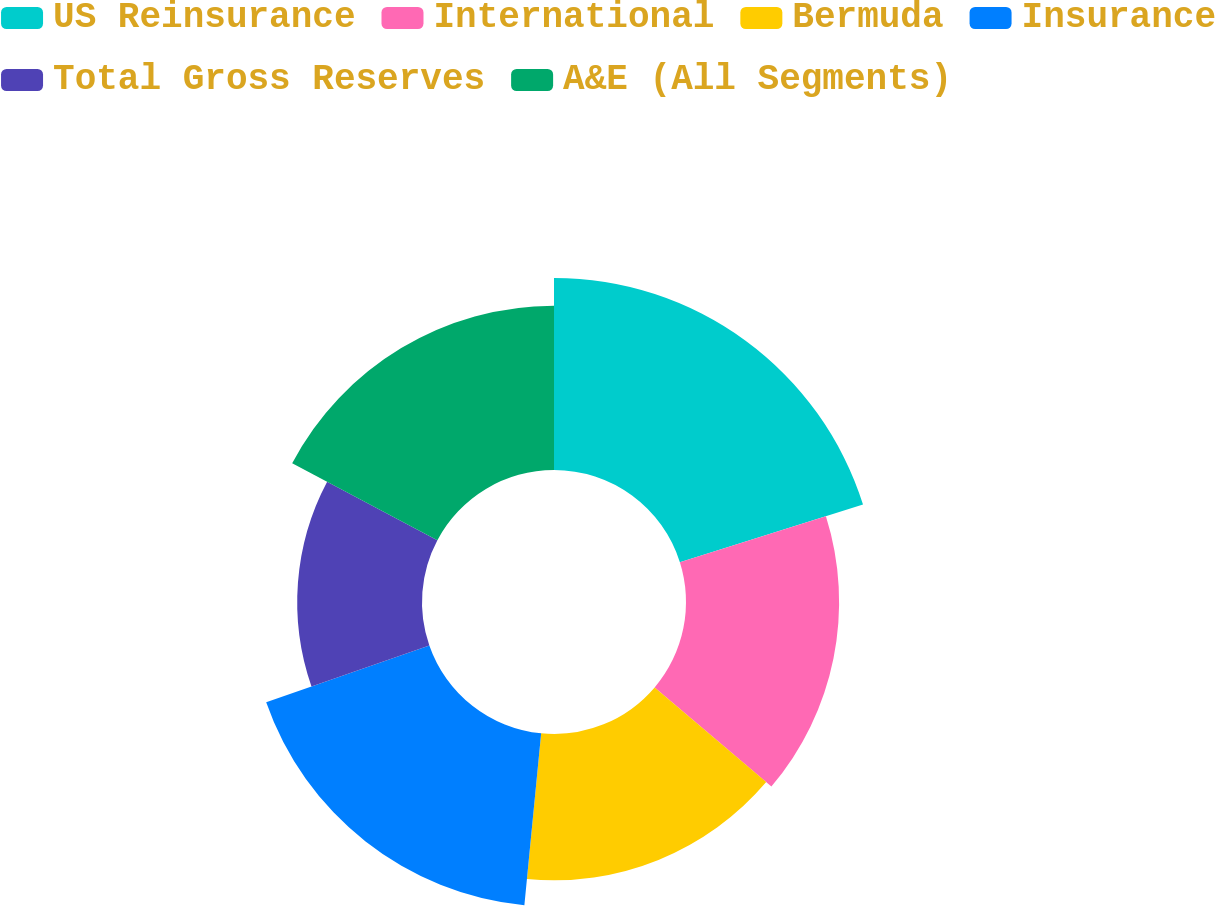Convert chart. <chart><loc_0><loc_0><loc_500><loc_500><pie_chart><fcel>US Reinsurance<fcel>International<fcel>Bermuda<fcel>Insurance<fcel>Total Gross Reserves<fcel>A&E (All Segments)<nl><fcel>20.14%<fcel>16.06%<fcel>15.35%<fcel>18.12%<fcel>13.09%<fcel>17.24%<nl></chart> 